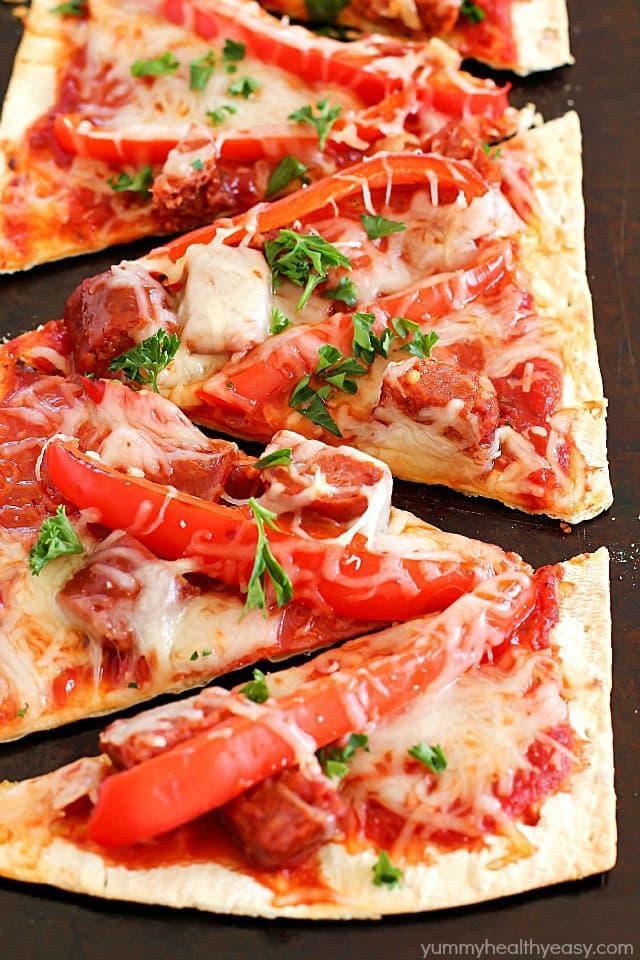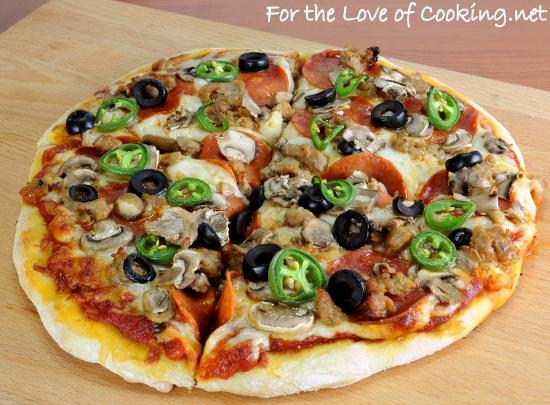The first image is the image on the left, the second image is the image on the right. Evaluate the accuracy of this statement regarding the images: "One or more pizzas contain pepperoni.". Is it true? Answer yes or no. Yes. 